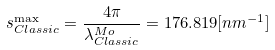<formula> <loc_0><loc_0><loc_500><loc_500>s ^ { \max } _ { C l a s s i c } = \frac { 4 \pi } { \lambda ^ { M o } _ { C l a s s i c } } = 1 7 6 . 8 1 9 [ n m ^ { - 1 } ]</formula> 